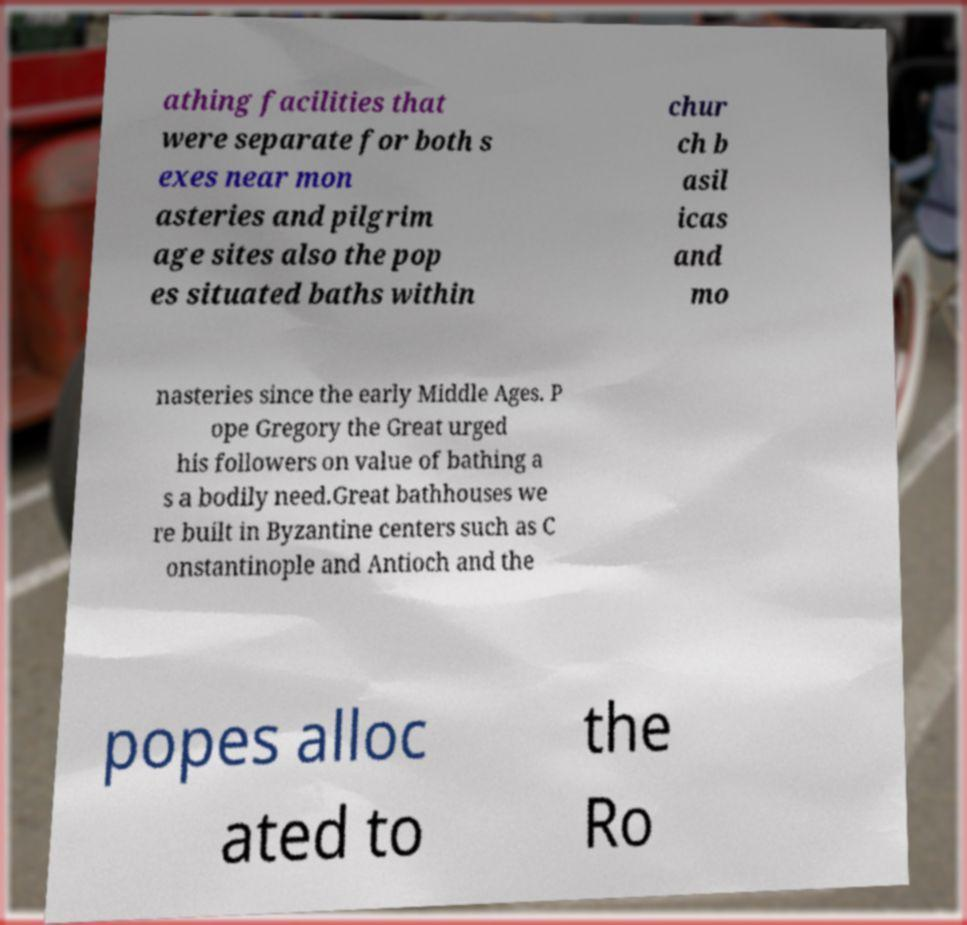Please read and relay the text visible in this image. What does it say? athing facilities that were separate for both s exes near mon asteries and pilgrim age sites also the pop es situated baths within chur ch b asil icas and mo nasteries since the early Middle Ages. P ope Gregory the Great urged his followers on value of bathing a s a bodily need.Great bathhouses we re built in Byzantine centers such as C onstantinople and Antioch and the popes alloc ated to the Ro 